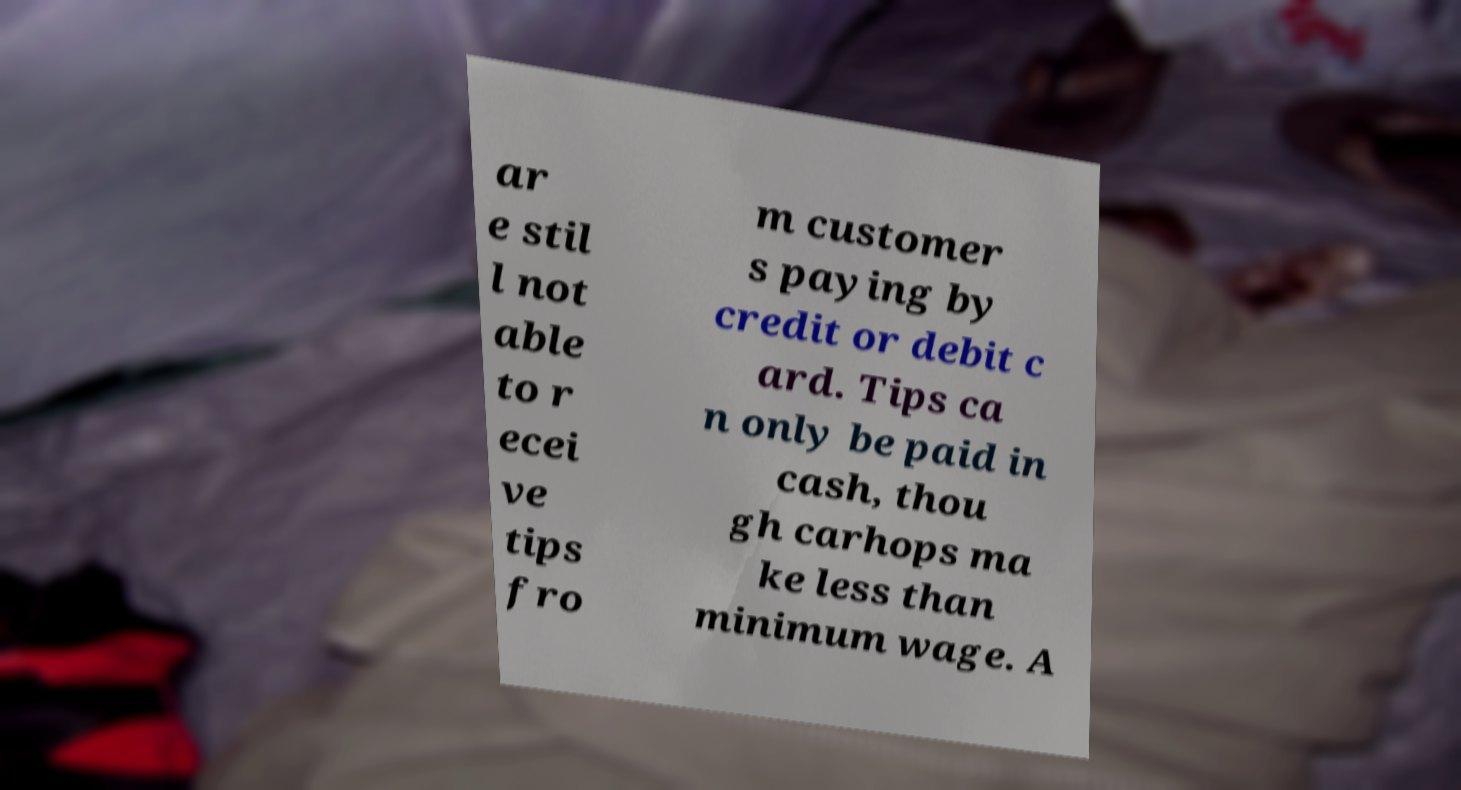Please read and relay the text visible in this image. What does it say? ar e stil l not able to r ecei ve tips fro m customer s paying by credit or debit c ard. Tips ca n only be paid in cash, thou gh carhops ma ke less than minimum wage. A 